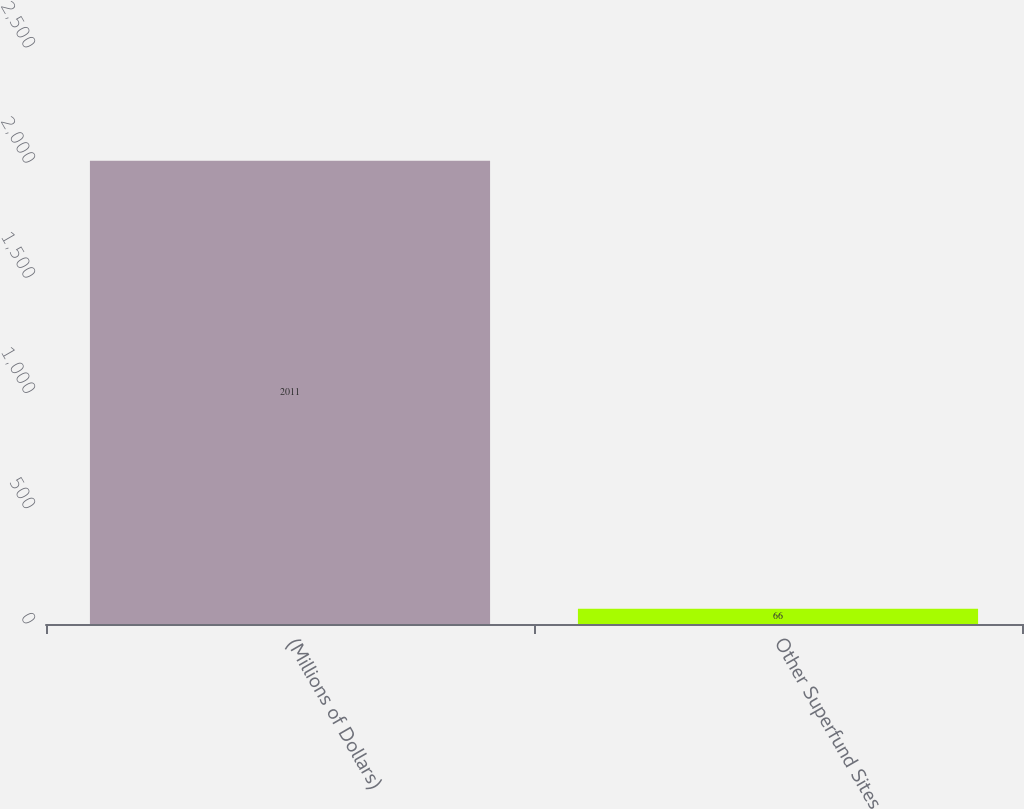Convert chart to OTSL. <chart><loc_0><loc_0><loc_500><loc_500><bar_chart><fcel>(Millions of Dollars)<fcel>Other Superfund Sites<nl><fcel>2011<fcel>66<nl></chart> 